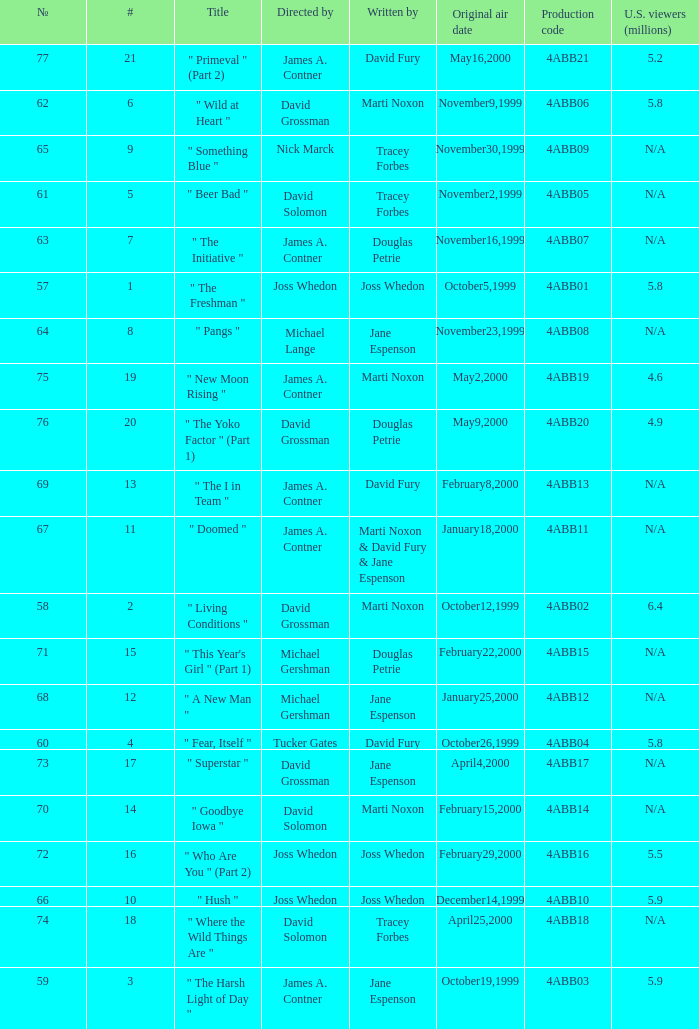Write the full table. {'header': ['№', '#', 'Title', 'Directed by', 'Written by', 'Original air date', 'Production code', 'U.S. viewers (millions)'], 'rows': [['77', '21', '" Primeval " (Part 2)', 'James A. Contner', 'David Fury', 'May16,2000', '4ABB21', '5.2'], ['62', '6', '" Wild at Heart "', 'David Grossman', 'Marti Noxon', 'November9,1999', '4ABB06', '5.8'], ['65', '9', '" Something Blue "', 'Nick Marck', 'Tracey Forbes', 'November30,1999', '4ABB09', 'N/A'], ['61', '5', '" Beer Bad "', 'David Solomon', 'Tracey Forbes', 'November2,1999', '4ABB05', 'N/A'], ['63', '7', '" The Initiative "', 'James A. Contner', 'Douglas Petrie', 'November16,1999', '4ABB07', 'N/A'], ['57', '1', '" The Freshman "', 'Joss Whedon', 'Joss Whedon', 'October5,1999', '4ABB01', '5.8'], ['64', '8', '" Pangs "', 'Michael Lange', 'Jane Espenson', 'November23,1999', '4ABB08', 'N/A'], ['75', '19', '" New Moon Rising "', 'James A. Contner', 'Marti Noxon', 'May2,2000', '4ABB19', '4.6'], ['76', '20', '" The Yoko Factor " (Part 1)', 'David Grossman', 'Douglas Petrie', 'May9,2000', '4ABB20', '4.9'], ['69', '13', '" The I in Team "', 'James A. Contner', 'David Fury', 'February8,2000', '4ABB13', 'N/A'], ['67', '11', '" Doomed "', 'James A. Contner', 'Marti Noxon & David Fury & Jane Espenson', 'January18,2000', '4ABB11', 'N/A'], ['58', '2', '" Living Conditions "', 'David Grossman', 'Marti Noxon', 'October12,1999', '4ABB02', '6.4'], ['71', '15', '" This Year\'s Girl " (Part 1)', 'Michael Gershman', 'Douglas Petrie', 'February22,2000', '4ABB15', 'N/A'], ['68', '12', '" A New Man "', 'Michael Gershman', 'Jane Espenson', 'January25,2000', '4ABB12', 'N/A'], ['60', '4', '" Fear, Itself "', 'Tucker Gates', 'David Fury', 'October26,1999', '4ABB04', '5.8'], ['73', '17', '" Superstar "', 'David Grossman', 'Jane Espenson', 'April4,2000', '4ABB17', 'N/A'], ['70', '14', '" Goodbye Iowa "', 'David Solomon', 'Marti Noxon', 'February15,2000', '4ABB14', 'N/A'], ['72', '16', '" Who Are You " (Part 2)', 'Joss Whedon', 'Joss Whedon', 'February29,2000', '4ABB16', '5.5'], ['66', '10', '" Hush "', 'Joss Whedon', 'Joss Whedon', 'December14,1999', '4ABB10', '5.9'], ['74', '18', '" Where the Wild Things Are "', 'David Solomon', 'Tracey Forbes', 'April25,2000', '4ABB18', 'N/A'], ['59', '3', '" The Harsh Light of Day "', 'James A. Contner', 'Jane Espenson', 'October19,1999', '4ABB03', '5.9']]} What is the season 4 # for the production code of 4abb07? 7.0. 